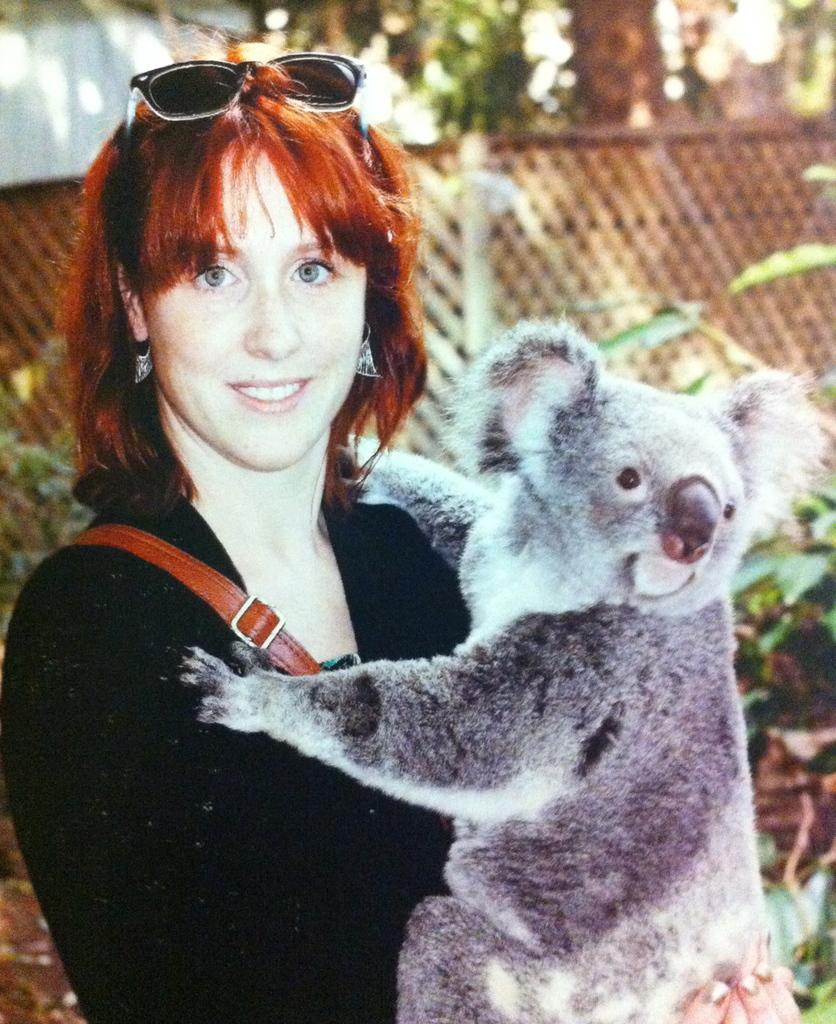What is happening in the image involving a person? There is a person in the image holding an animal. Can you describe the animal being held by the person? Unfortunately, the specific animal cannot be identified from the provided facts. What can be seen in the background of the image? There is a fence in the background of the image. What else is present in the image besides the person and the fence? There are plants in the image. Can you describe the harbor in the image? There is no harbor present in the image. What type of ray is visible in the image? There is no ray present in the image. 